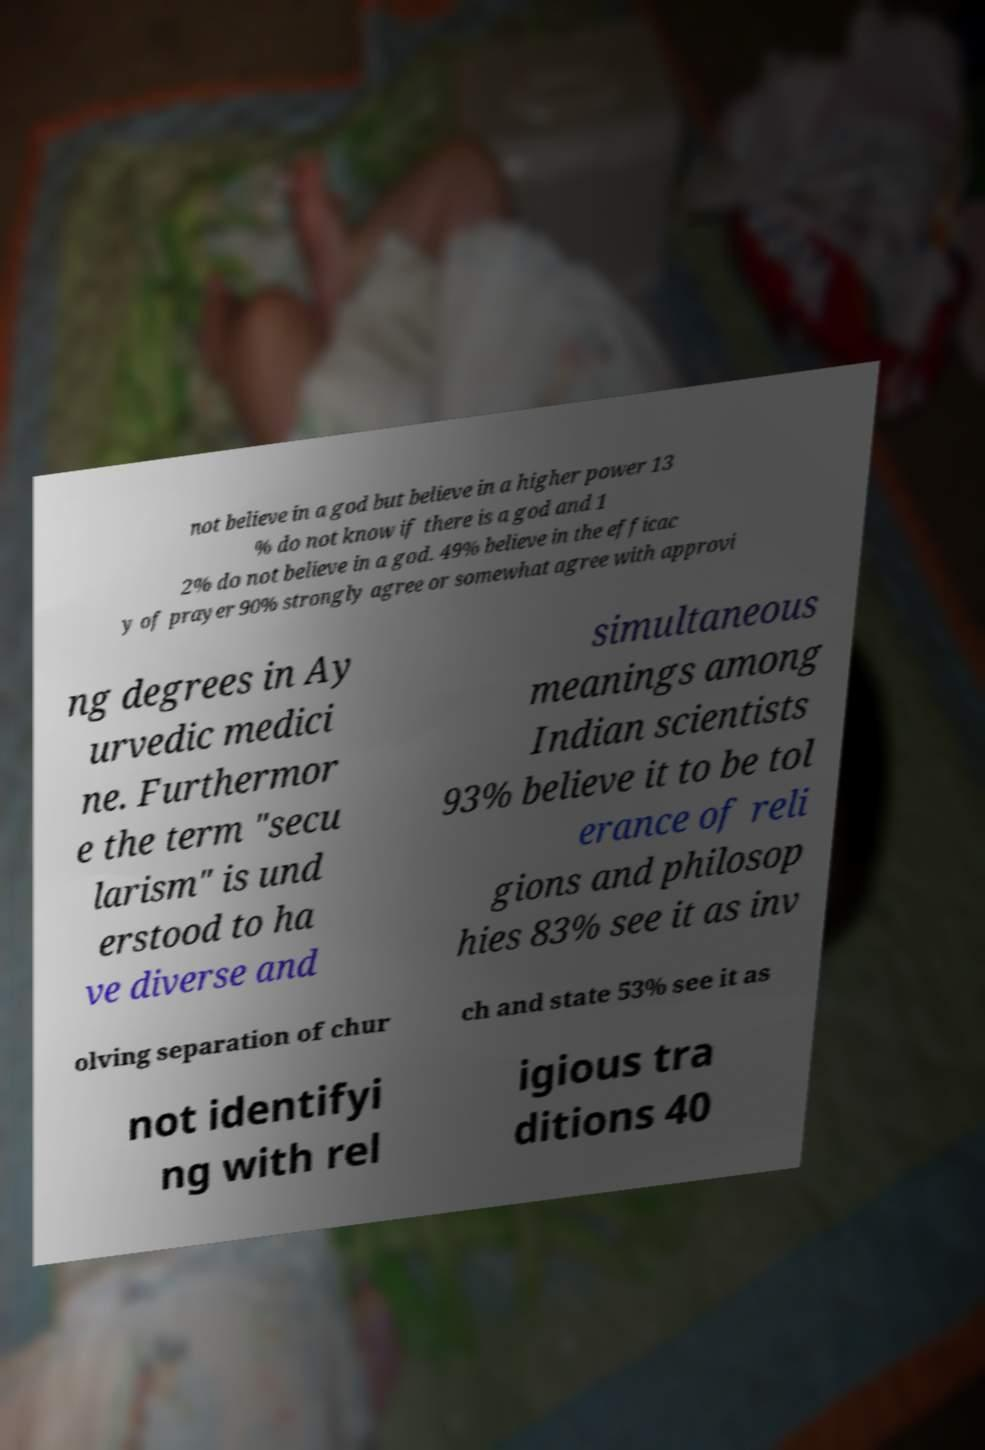Please identify and transcribe the text found in this image. not believe in a god but believe in a higher power 13 % do not know if there is a god and 1 2% do not believe in a god. 49% believe in the efficac y of prayer 90% strongly agree or somewhat agree with approvi ng degrees in Ay urvedic medici ne. Furthermor e the term "secu larism" is und erstood to ha ve diverse and simultaneous meanings among Indian scientists 93% believe it to be tol erance of reli gions and philosop hies 83% see it as inv olving separation of chur ch and state 53% see it as not identifyi ng with rel igious tra ditions 40 